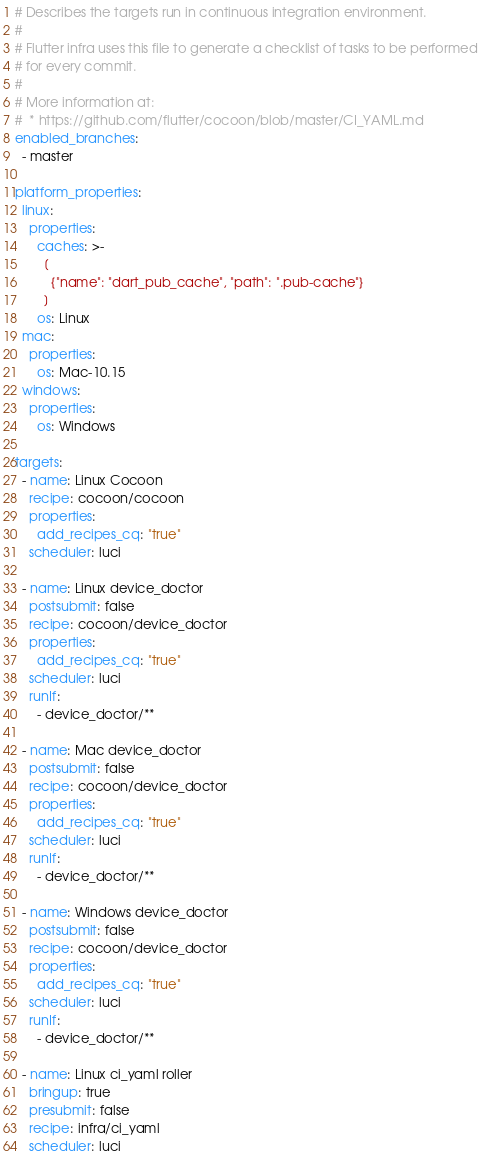Convert code to text. <code><loc_0><loc_0><loc_500><loc_500><_YAML_># Describes the targets run in continuous integration environment.
#
# Flutter infra uses this file to generate a checklist of tasks to be performed
# for every commit.
#
# More information at:
#  * https://github.com/flutter/cocoon/blob/master/CI_YAML.md
enabled_branches:
  - master

platform_properties:
  linux:
    properties:
      caches: >-
        [
          {"name": "dart_pub_cache", "path": ".pub-cache"}
        ]
      os: Linux
  mac:
    properties:
      os: Mac-10.15
  windows:
    properties:
      os: Windows

targets:
  - name: Linux Cocoon
    recipe: cocoon/cocoon
    properties:
      add_recipes_cq: "true"
    scheduler: luci

  - name: Linux device_doctor
    postsubmit: false
    recipe: cocoon/device_doctor
    properties:
      add_recipes_cq: "true"
    scheduler: luci
    runIf:
      - device_doctor/**

  - name: Mac device_doctor
    postsubmit: false
    recipe: cocoon/device_doctor
    properties:
      add_recipes_cq: "true"
    scheduler: luci
    runIf:
      - device_doctor/**

  - name: Windows device_doctor
    postsubmit: false
    recipe: cocoon/device_doctor
    properties:
      add_recipes_cq: "true"
    scheduler: luci
    runIf:
      - device_doctor/**

  - name: Linux ci_yaml roller
    bringup: true
    presubmit: false
    recipe: infra/ci_yaml
    scheduler: luci
</code> 